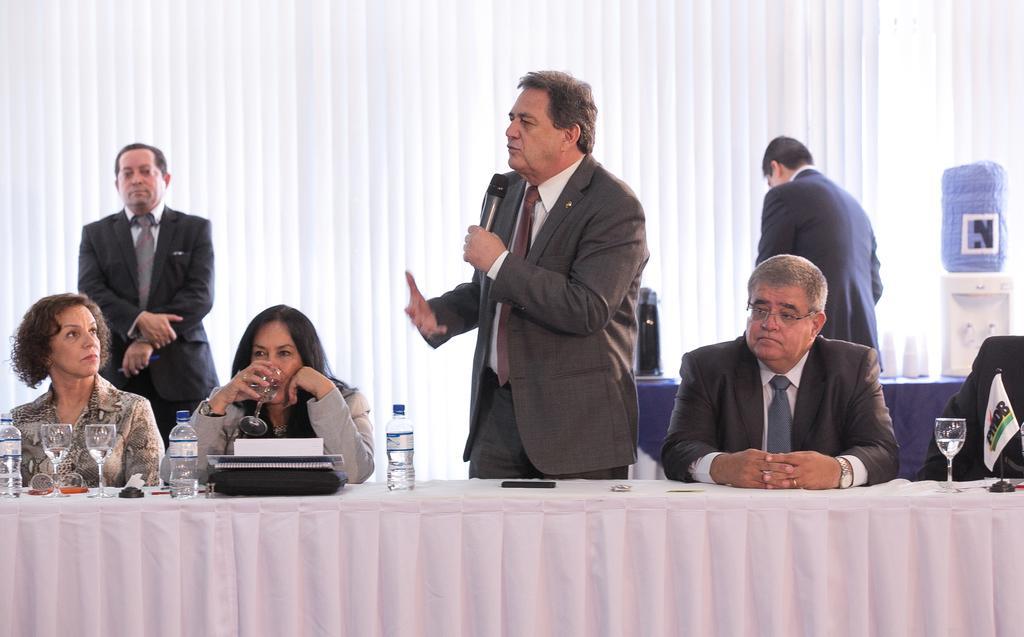Could you give a brief overview of what you see in this image? This is a image taken in a meeting. In the foreground of the picture there is a desk covered with cloth, on the desk there are water bottles, glasses, books and flag. Behind the desk there are few people. In the background there is a white curtain on the right there is a desk and water machine. 